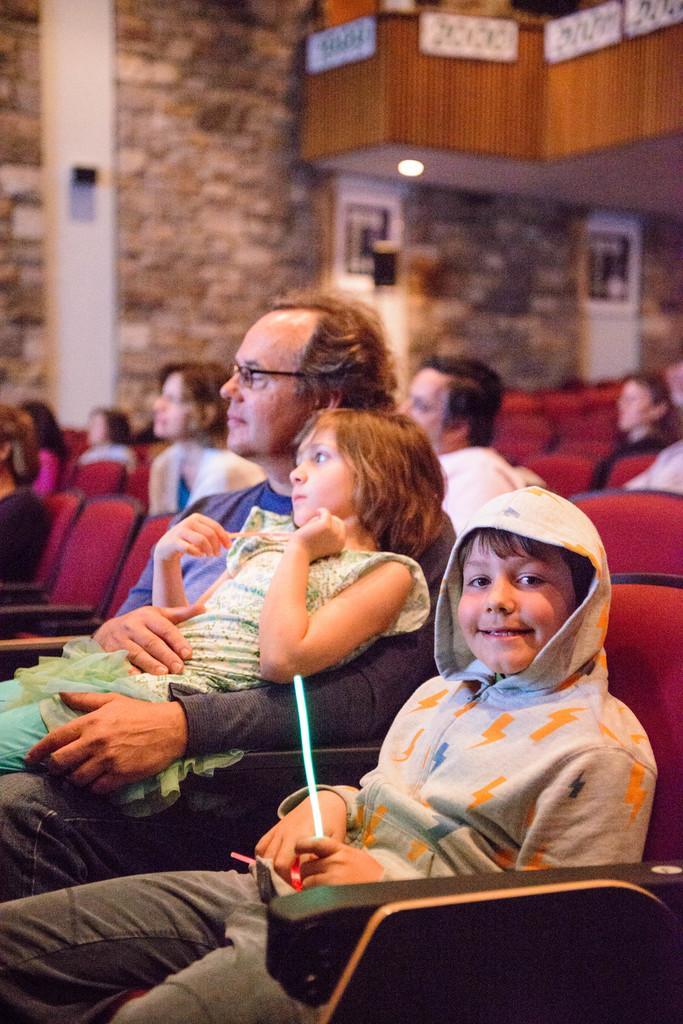Could you give a brief overview of what you see in this image? This picture is clicked inside the auditorium. In this image there is a boy sitting in the chair. Beside him there is a man who is sitting in the chair by holding the girl. In the background there are so many chairs on which there are people. In the background there is a wall. At the top there is another floor to which there is a light. 